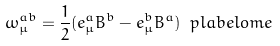Convert formula to latex. <formula><loc_0><loc_0><loc_500><loc_500>\omega _ { \mu } ^ { a b } = \frac { 1 } { 2 } ( e ^ { a } _ { \mu } B ^ { b } - e ^ { b } _ { \mu } B ^ { a } ) \ p l a b e l { o m e }</formula> 